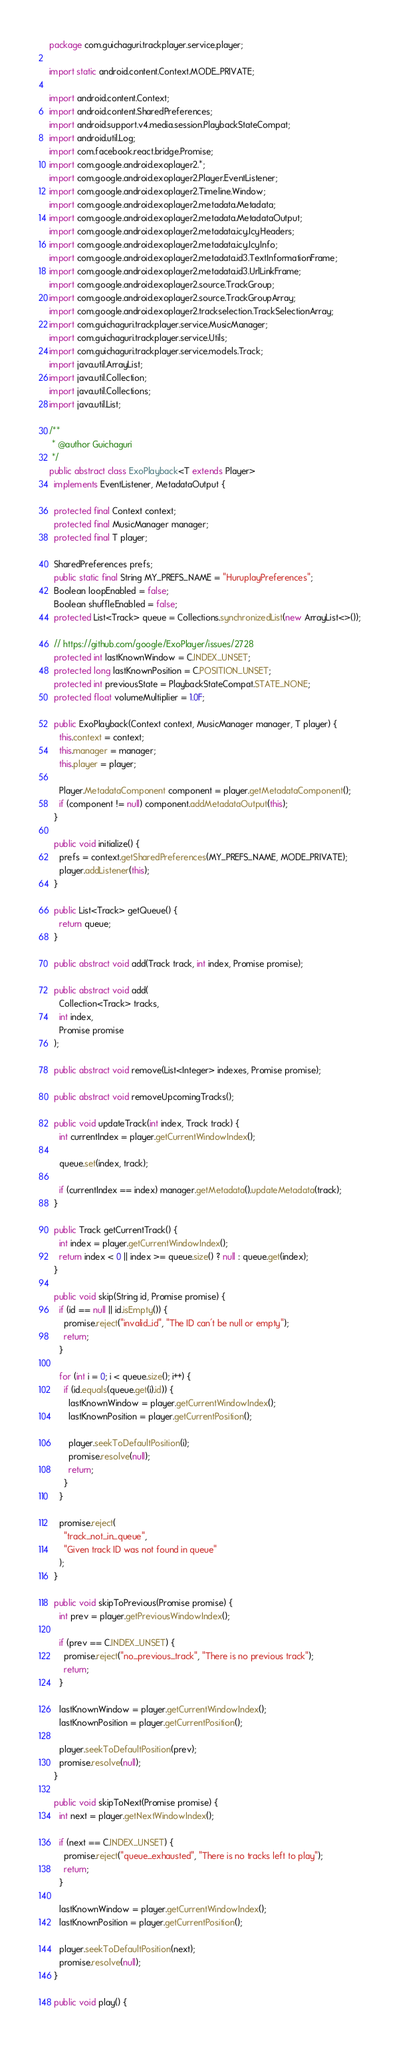<code> <loc_0><loc_0><loc_500><loc_500><_Java_>package com.guichaguri.trackplayer.service.player;

import static android.content.Context.MODE_PRIVATE;

import android.content.Context;
import android.content.SharedPreferences; 
import android.support.v4.media.session.PlaybackStateCompat;
import android.util.Log;
import com.facebook.react.bridge.Promise;
import com.google.android.exoplayer2.*;
import com.google.android.exoplayer2.Player.EventListener;
import com.google.android.exoplayer2.Timeline.Window;
import com.google.android.exoplayer2.metadata.Metadata;
import com.google.android.exoplayer2.metadata.MetadataOutput;
import com.google.android.exoplayer2.metadata.icy.IcyHeaders;
import com.google.android.exoplayer2.metadata.icy.IcyInfo;
import com.google.android.exoplayer2.metadata.id3.TextInformationFrame;
import com.google.android.exoplayer2.metadata.id3.UrlLinkFrame;
import com.google.android.exoplayer2.source.TrackGroup;
import com.google.android.exoplayer2.source.TrackGroupArray;
import com.google.android.exoplayer2.trackselection.TrackSelectionArray;
import com.guichaguri.trackplayer.service.MusicManager;
import com.guichaguri.trackplayer.service.Utils;
import com.guichaguri.trackplayer.service.models.Track;
import java.util.ArrayList;
import java.util.Collection;
import java.util.Collections;
import java.util.List;

/**
 * @author Guichaguri
 */
public abstract class ExoPlayback<T extends Player>
  implements EventListener, MetadataOutput {

  protected final Context context;
  protected final MusicManager manager;
  protected final T player;

  SharedPreferences prefs;
  public static final String MY_PREFS_NAME = "HuruplayPreferences";
  Boolean loopEnabled = false;
  Boolean shuffleEnabled = false;
  protected List<Track> queue = Collections.synchronizedList(new ArrayList<>());

  // https://github.com/google/ExoPlayer/issues/2728
  protected int lastKnownWindow = C.INDEX_UNSET;
  protected long lastKnownPosition = C.POSITION_UNSET;
  protected int previousState = PlaybackStateCompat.STATE_NONE;
  protected float volumeMultiplier = 1.0F;

  public ExoPlayback(Context context, MusicManager manager, T player) {
    this.context = context;
    this.manager = manager;
    this.player = player;

    Player.MetadataComponent component = player.getMetadataComponent();
    if (component != null) component.addMetadataOutput(this);
  }

  public void initialize() {
    prefs = context.getSharedPreferences(MY_PREFS_NAME, MODE_PRIVATE);
    player.addListener(this);
  }

  public List<Track> getQueue() {
    return queue;
  }

  public abstract void add(Track track, int index, Promise promise);

  public abstract void add(
    Collection<Track> tracks,
    int index,
    Promise promise
  );

  public abstract void remove(List<Integer> indexes, Promise promise);

  public abstract void removeUpcomingTracks();

  public void updateTrack(int index, Track track) {
    int currentIndex = player.getCurrentWindowIndex();

    queue.set(index, track);

    if (currentIndex == index) manager.getMetadata().updateMetadata(track);
  }

  public Track getCurrentTrack() {
    int index = player.getCurrentWindowIndex();
    return index < 0 || index >= queue.size() ? null : queue.get(index);
  }

  public void skip(String id, Promise promise) {
    if (id == null || id.isEmpty()) {
      promise.reject("invalid_id", "The ID can't be null or empty");
      return;
    }

    for (int i = 0; i < queue.size(); i++) {
      if (id.equals(queue.get(i).id)) {
        lastKnownWindow = player.getCurrentWindowIndex();
        lastKnownPosition = player.getCurrentPosition();

        player.seekToDefaultPosition(i);
        promise.resolve(null);
        return;
      }
    }

    promise.reject(
      "track_not_in_queue",
      "Given track ID was not found in queue"
    );
  }

  public void skipToPrevious(Promise promise) {
    int prev = player.getPreviousWindowIndex();

    if (prev == C.INDEX_UNSET) {
      promise.reject("no_previous_track", "There is no previous track");
      return;
    }

    lastKnownWindow = player.getCurrentWindowIndex();
    lastKnownPosition = player.getCurrentPosition();

    player.seekToDefaultPosition(prev);
    promise.resolve(null);
  }

  public void skipToNext(Promise promise) {
    int next = player.getNextWindowIndex();

    if (next == C.INDEX_UNSET) {
      promise.reject("queue_exhausted", "There is no tracks left to play");
      return;
    }

    lastKnownWindow = player.getCurrentWindowIndex();
    lastKnownPosition = player.getCurrentPosition();

    player.seekToDefaultPosition(next);
    promise.resolve(null);
  }

  public void play() {</code> 